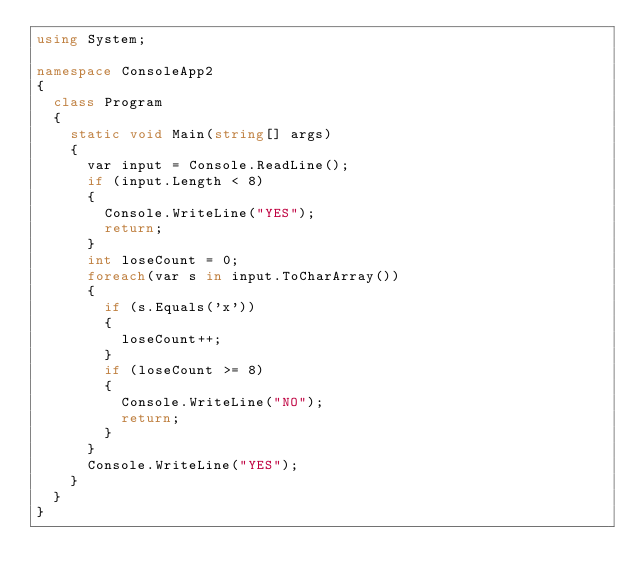<code> <loc_0><loc_0><loc_500><loc_500><_C#_>using System;

namespace ConsoleApp2
{
	class Program
	{
		static void Main(string[] args)
		{
			var input = Console.ReadLine();
			if (input.Length < 8)
			{
				Console.WriteLine("YES");
				return;
			}
			int loseCount = 0;
			foreach(var s in input.ToCharArray())
			{
				if (s.Equals('x'))
				{
					loseCount++;
				}
				if (loseCount >= 8)
				{
					Console.WriteLine("NO");
					return;
				}
			}
			Console.WriteLine("YES");
		}
	}
}
</code> 